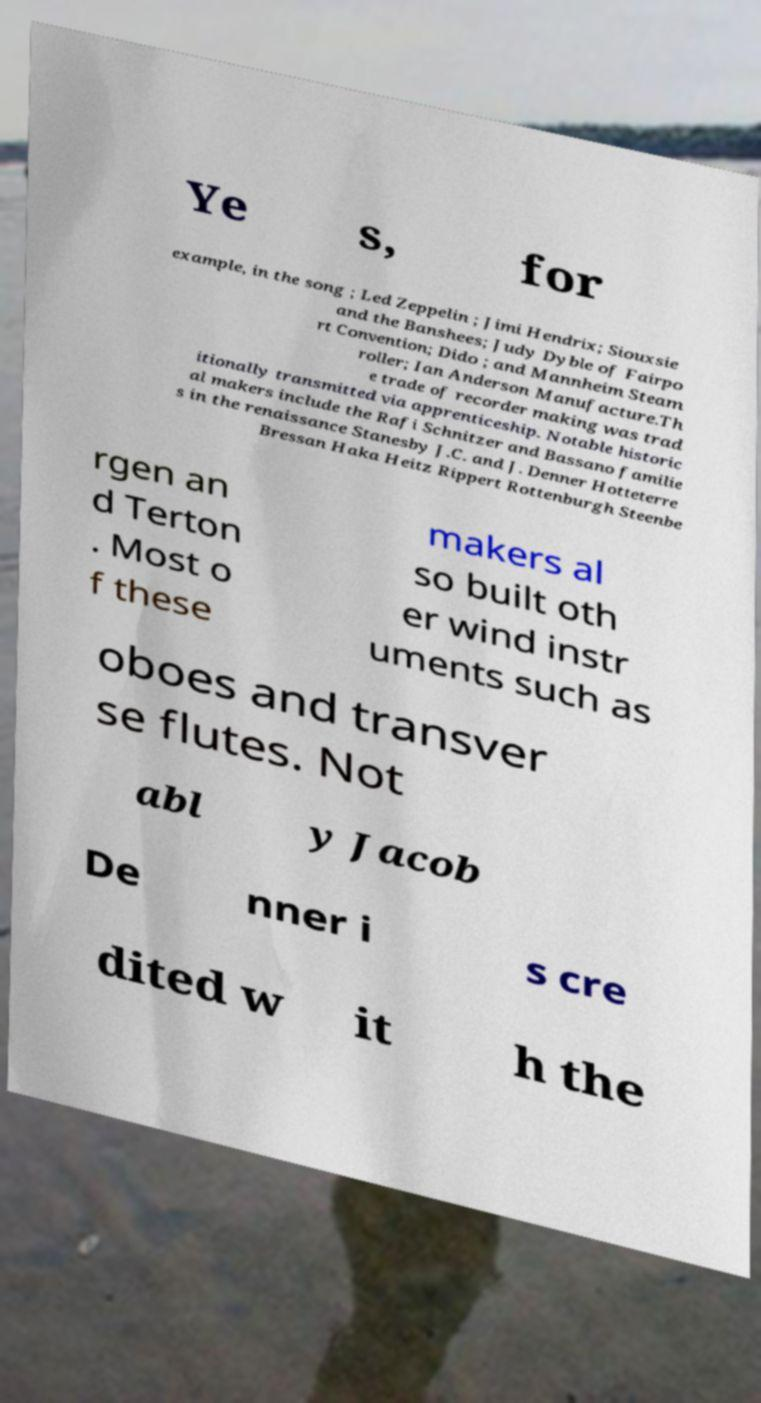I need the written content from this picture converted into text. Can you do that? Ye s, for example, in the song ; Led Zeppelin ; Jimi Hendrix; Siouxsie and the Banshees; Judy Dyble of Fairpo rt Convention; Dido ; and Mannheim Steam roller; Ian Anderson Manufacture.Th e trade of recorder making was trad itionally transmitted via apprenticeship. Notable historic al makers include the Rafi Schnitzer and Bassano familie s in the renaissance Stanesby J.C. and J. Denner Hotteterre Bressan Haka Heitz Rippert Rottenburgh Steenbe rgen an d Terton . Most o f these makers al so built oth er wind instr uments such as oboes and transver se flutes. Not abl y Jacob De nner i s cre dited w it h the 